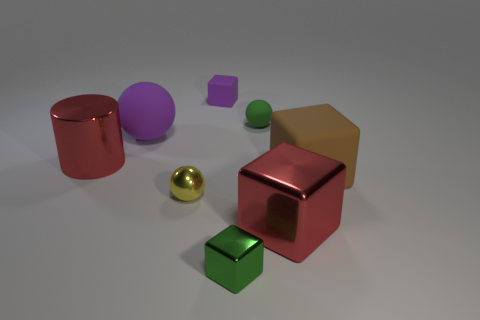Subtract all red cubes. How many cubes are left? 3 Subtract 1 cylinders. How many cylinders are left? 0 Subtract all balls. How many objects are left? 5 Subtract all green balls. How many balls are left? 2 Add 2 big objects. How many objects exist? 10 Add 5 small blocks. How many small blocks are left? 7 Add 5 large blue shiny things. How many large blue shiny things exist? 5 Subtract 0 blue cubes. How many objects are left? 8 Subtract all gray spheres. Subtract all yellow cylinders. How many spheres are left? 3 Subtract all brown balls. How many purple cylinders are left? 0 